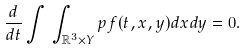Convert formula to latex. <formula><loc_0><loc_0><loc_500><loc_500>\frac { d } { d t } \int \, \int _ { \mathbb { R } ^ { 3 } \times Y } p f ( t , x , y ) d x d y = 0 .</formula> 